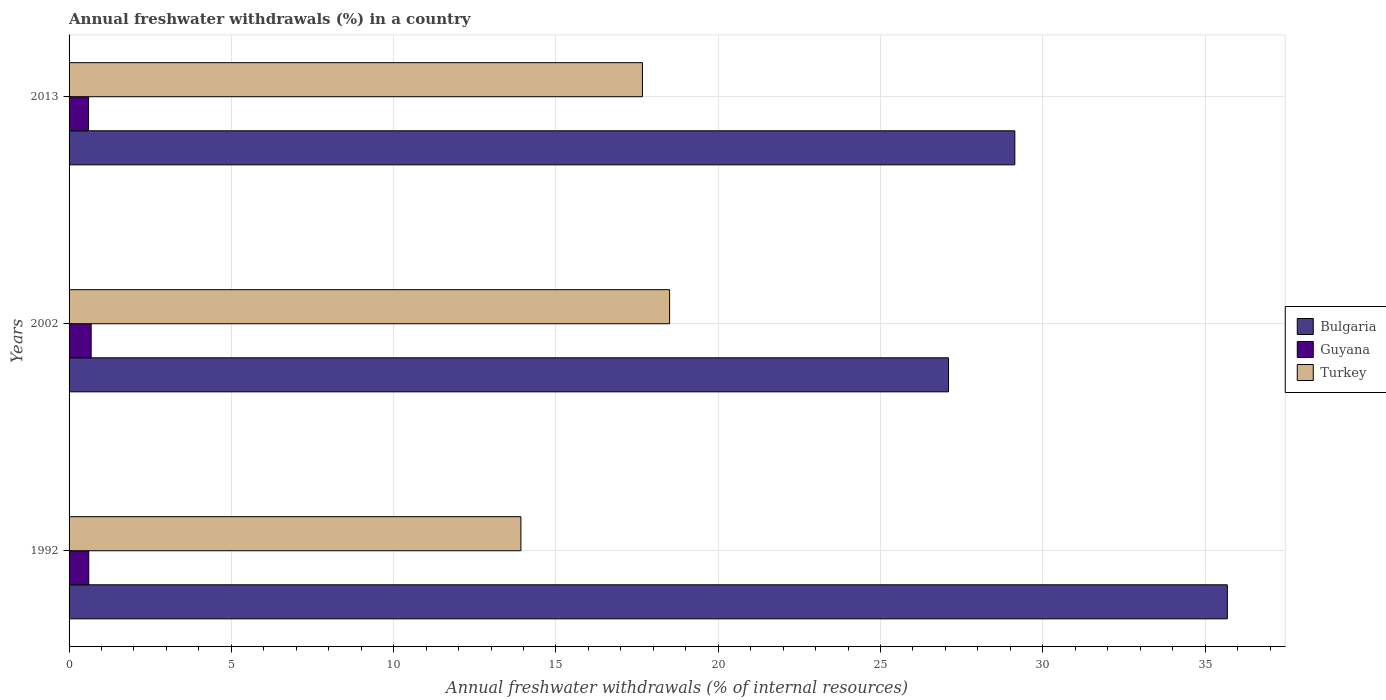How many different coloured bars are there?
Offer a terse response. 3. How many groups of bars are there?
Offer a very short reply. 3. Are the number of bars on each tick of the Y-axis equal?
Provide a short and direct response. Yes. How many bars are there on the 1st tick from the top?
Your response must be concise. 3. What is the label of the 3rd group of bars from the top?
Make the answer very short. 1992. What is the percentage of annual freshwater withdrawals in Bulgaria in 2013?
Your answer should be very brief. 29.14. Across all years, what is the maximum percentage of annual freshwater withdrawals in Turkey?
Your response must be concise. 18.5. Across all years, what is the minimum percentage of annual freshwater withdrawals in Turkey?
Offer a very short reply. 13.92. What is the total percentage of annual freshwater withdrawals in Guyana in the graph?
Your answer should be compact. 1.89. What is the difference between the percentage of annual freshwater withdrawals in Guyana in 2002 and that in 2013?
Provide a succinct answer. 0.08. What is the difference between the percentage of annual freshwater withdrawals in Turkey in 1992 and the percentage of annual freshwater withdrawals in Guyana in 2013?
Your answer should be compact. 13.32. What is the average percentage of annual freshwater withdrawals in Bulgaria per year?
Ensure brevity in your answer.  30.64. In the year 1992, what is the difference between the percentage of annual freshwater withdrawals in Guyana and percentage of annual freshwater withdrawals in Bulgaria?
Make the answer very short. -35.08. In how many years, is the percentage of annual freshwater withdrawals in Bulgaria greater than 27 %?
Your answer should be compact. 3. What is the ratio of the percentage of annual freshwater withdrawals in Turkey in 1992 to that in 2002?
Make the answer very short. 0.75. Is the difference between the percentage of annual freshwater withdrawals in Guyana in 1992 and 2002 greater than the difference between the percentage of annual freshwater withdrawals in Bulgaria in 1992 and 2002?
Ensure brevity in your answer.  No. What is the difference between the highest and the second highest percentage of annual freshwater withdrawals in Bulgaria?
Keep it short and to the point. 6.55. What is the difference between the highest and the lowest percentage of annual freshwater withdrawals in Turkey?
Provide a short and direct response. 4.58. In how many years, is the percentage of annual freshwater withdrawals in Guyana greater than the average percentage of annual freshwater withdrawals in Guyana taken over all years?
Make the answer very short. 1. What does the 3rd bar from the top in 2002 represents?
Give a very brief answer. Bulgaria. What does the 2nd bar from the bottom in 1992 represents?
Your response must be concise. Guyana. Are all the bars in the graph horizontal?
Provide a short and direct response. Yes. What is the difference between two consecutive major ticks on the X-axis?
Provide a short and direct response. 5. Does the graph contain grids?
Offer a terse response. Yes. Where does the legend appear in the graph?
Provide a short and direct response. Center right. What is the title of the graph?
Provide a succinct answer. Annual freshwater withdrawals (%) in a country. Does "Myanmar" appear as one of the legend labels in the graph?
Provide a short and direct response. No. What is the label or title of the X-axis?
Give a very brief answer. Annual freshwater withdrawals (% of internal resources). What is the label or title of the Y-axis?
Give a very brief answer. Years. What is the Annual freshwater withdrawals (% of internal resources) of Bulgaria in 1992?
Give a very brief answer. 35.69. What is the Annual freshwater withdrawals (% of internal resources) of Guyana in 1992?
Provide a succinct answer. 0.61. What is the Annual freshwater withdrawals (% of internal resources) in Turkey in 1992?
Your answer should be compact. 13.92. What is the Annual freshwater withdrawals (% of internal resources) of Bulgaria in 2002?
Keep it short and to the point. 27.1. What is the Annual freshwater withdrawals (% of internal resources) of Guyana in 2002?
Provide a short and direct response. 0.68. What is the Annual freshwater withdrawals (% of internal resources) in Turkey in 2002?
Offer a very short reply. 18.5. What is the Annual freshwater withdrawals (% of internal resources) of Bulgaria in 2013?
Ensure brevity in your answer.  29.14. What is the Annual freshwater withdrawals (% of internal resources) in Guyana in 2013?
Your answer should be compact. 0.6. What is the Annual freshwater withdrawals (% of internal resources) of Turkey in 2013?
Make the answer very short. 17.67. Across all years, what is the maximum Annual freshwater withdrawals (% of internal resources) in Bulgaria?
Keep it short and to the point. 35.69. Across all years, what is the maximum Annual freshwater withdrawals (% of internal resources) of Guyana?
Keep it short and to the point. 0.68. Across all years, what is the maximum Annual freshwater withdrawals (% of internal resources) of Turkey?
Your answer should be compact. 18.5. Across all years, what is the minimum Annual freshwater withdrawals (% of internal resources) in Bulgaria?
Give a very brief answer. 27.1. Across all years, what is the minimum Annual freshwater withdrawals (% of internal resources) in Guyana?
Your response must be concise. 0.6. Across all years, what is the minimum Annual freshwater withdrawals (% of internal resources) of Turkey?
Your response must be concise. 13.92. What is the total Annual freshwater withdrawals (% of internal resources) of Bulgaria in the graph?
Offer a terse response. 91.92. What is the total Annual freshwater withdrawals (% of internal resources) of Guyana in the graph?
Offer a very short reply. 1.89. What is the total Annual freshwater withdrawals (% of internal resources) of Turkey in the graph?
Give a very brief answer. 50.09. What is the difference between the Annual freshwater withdrawals (% of internal resources) in Bulgaria in 1992 and that in 2002?
Your response must be concise. 8.59. What is the difference between the Annual freshwater withdrawals (% of internal resources) in Guyana in 1992 and that in 2002?
Your answer should be compact. -0.07. What is the difference between the Annual freshwater withdrawals (% of internal resources) in Turkey in 1992 and that in 2002?
Your answer should be compact. -4.58. What is the difference between the Annual freshwater withdrawals (% of internal resources) of Bulgaria in 1992 and that in 2013?
Give a very brief answer. 6.55. What is the difference between the Annual freshwater withdrawals (% of internal resources) of Guyana in 1992 and that in 2013?
Make the answer very short. 0.01. What is the difference between the Annual freshwater withdrawals (% of internal resources) in Turkey in 1992 and that in 2013?
Provide a short and direct response. -3.74. What is the difference between the Annual freshwater withdrawals (% of internal resources) in Bulgaria in 2002 and that in 2013?
Offer a very short reply. -2.04. What is the difference between the Annual freshwater withdrawals (% of internal resources) in Guyana in 2002 and that in 2013?
Provide a succinct answer. 0.08. What is the difference between the Annual freshwater withdrawals (% of internal resources) of Turkey in 2002 and that in 2013?
Offer a terse response. 0.84. What is the difference between the Annual freshwater withdrawals (% of internal resources) in Bulgaria in 1992 and the Annual freshwater withdrawals (% of internal resources) in Guyana in 2002?
Make the answer very short. 35.01. What is the difference between the Annual freshwater withdrawals (% of internal resources) of Bulgaria in 1992 and the Annual freshwater withdrawals (% of internal resources) of Turkey in 2002?
Offer a very short reply. 17.18. What is the difference between the Annual freshwater withdrawals (% of internal resources) of Guyana in 1992 and the Annual freshwater withdrawals (% of internal resources) of Turkey in 2002?
Ensure brevity in your answer.  -17.9. What is the difference between the Annual freshwater withdrawals (% of internal resources) of Bulgaria in 1992 and the Annual freshwater withdrawals (% of internal resources) of Guyana in 2013?
Provide a short and direct response. 35.09. What is the difference between the Annual freshwater withdrawals (% of internal resources) in Bulgaria in 1992 and the Annual freshwater withdrawals (% of internal resources) in Turkey in 2013?
Offer a very short reply. 18.02. What is the difference between the Annual freshwater withdrawals (% of internal resources) in Guyana in 1992 and the Annual freshwater withdrawals (% of internal resources) in Turkey in 2013?
Provide a succinct answer. -17.06. What is the difference between the Annual freshwater withdrawals (% of internal resources) of Bulgaria in 2002 and the Annual freshwater withdrawals (% of internal resources) of Guyana in 2013?
Offer a terse response. 26.5. What is the difference between the Annual freshwater withdrawals (% of internal resources) of Bulgaria in 2002 and the Annual freshwater withdrawals (% of internal resources) of Turkey in 2013?
Your answer should be compact. 9.43. What is the difference between the Annual freshwater withdrawals (% of internal resources) in Guyana in 2002 and the Annual freshwater withdrawals (% of internal resources) in Turkey in 2013?
Your response must be concise. -16.98. What is the average Annual freshwater withdrawals (% of internal resources) of Bulgaria per year?
Make the answer very short. 30.64. What is the average Annual freshwater withdrawals (% of internal resources) in Guyana per year?
Your answer should be compact. 0.63. What is the average Annual freshwater withdrawals (% of internal resources) in Turkey per year?
Keep it short and to the point. 16.7. In the year 1992, what is the difference between the Annual freshwater withdrawals (% of internal resources) in Bulgaria and Annual freshwater withdrawals (% of internal resources) in Guyana?
Offer a terse response. 35.08. In the year 1992, what is the difference between the Annual freshwater withdrawals (% of internal resources) in Bulgaria and Annual freshwater withdrawals (% of internal resources) in Turkey?
Ensure brevity in your answer.  21.77. In the year 1992, what is the difference between the Annual freshwater withdrawals (% of internal resources) in Guyana and Annual freshwater withdrawals (% of internal resources) in Turkey?
Provide a short and direct response. -13.31. In the year 2002, what is the difference between the Annual freshwater withdrawals (% of internal resources) of Bulgaria and Annual freshwater withdrawals (% of internal resources) of Guyana?
Give a very brief answer. 26.41. In the year 2002, what is the difference between the Annual freshwater withdrawals (% of internal resources) of Bulgaria and Annual freshwater withdrawals (% of internal resources) of Turkey?
Ensure brevity in your answer.  8.59. In the year 2002, what is the difference between the Annual freshwater withdrawals (% of internal resources) in Guyana and Annual freshwater withdrawals (% of internal resources) in Turkey?
Provide a short and direct response. -17.82. In the year 2013, what is the difference between the Annual freshwater withdrawals (% of internal resources) of Bulgaria and Annual freshwater withdrawals (% of internal resources) of Guyana?
Give a very brief answer. 28.54. In the year 2013, what is the difference between the Annual freshwater withdrawals (% of internal resources) of Bulgaria and Annual freshwater withdrawals (% of internal resources) of Turkey?
Give a very brief answer. 11.47. In the year 2013, what is the difference between the Annual freshwater withdrawals (% of internal resources) in Guyana and Annual freshwater withdrawals (% of internal resources) in Turkey?
Your answer should be compact. -17.07. What is the ratio of the Annual freshwater withdrawals (% of internal resources) of Bulgaria in 1992 to that in 2002?
Ensure brevity in your answer.  1.32. What is the ratio of the Annual freshwater withdrawals (% of internal resources) of Guyana in 1992 to that in 2002?
Ensure brevity in your answer.  0.89. What is the ratio of the Annual freshwater withdrawals (% of internal resources) in Turkey in 1992 to that in 2002?
Provide a short and direct response. 0.75. What is the ratio of the Annual freshwater withdrawals (% of internal resources) in Bulgaria in 1992 to that in 2013?
Ensure brevity in your answer.  1.22. What is the ratio of the Annual freshwater withdrawals (% of internal resources) of Guyana in 1992 to that in 2013?
Provide a succinct answer. 1.01. What is the ratio of the Annual freshwater withdrawals (% of internal resources) of Turkey in 1992 to that in 2013?
Offer a terse response. 0.79. What is the ratio of the Annual freshwater withdrawals (% of internal resources) of Bulgaria in 2002 to that in 2013?
Your answer should be very brief. 0.93. What is the ratio of the Annual freshwater withdrawals (% of internal resources) of Guyana in 2002 to that in 2013?
Provide a succinct answer. 1.13. What is the ratio of the Annual freshwater withdrawals (% of internal resources) in Turkey in 2002 to that in 2013?
Offer a very short reply. 1.05. What is the difference between the highest and the second highest Annual freshwater withdrawals (% of internal resources) of Bulgaria?
Provide a succinct answer. 6.55. What is the difference between the highest and the second highest Annual freshwater withdrawals (% of internal resources) in Guyana?
Your answer should be very brief. 0.07. What is the difference between the highest and the second highest Annual freshwater withdrawals (% of internal resources) in Turkey?
Offer a very short reply. 0.84. What is the difference between the highest and the lowest Annual freshwater withdrawals (% of internal resources) in Bulgaria?
Provide a succinct answer. 8.59. What is the difference between the highest and the lowest Annual freshwater withdrawals (% of internal resources) of Guyana?
Provide a succinct answer. 0.08. What is the difference between the highest and the lowest Annual freshwater withdrawals (% of internal resources) in Turkey?
Ensure brevity in your answer.  4.58. 